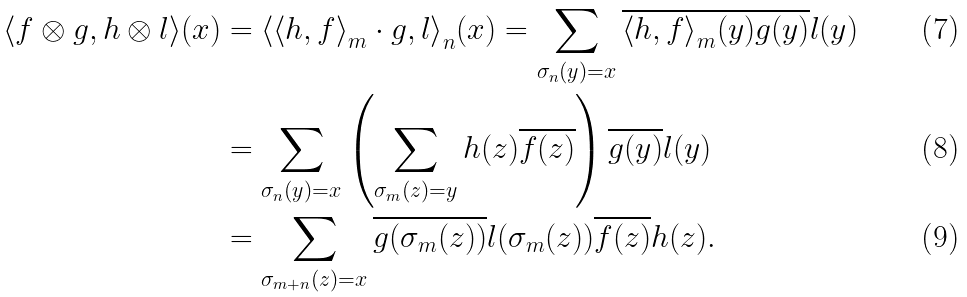Convert formula to latex. <formula><loc_0><loc_0><loc_500><loc_500>\langle f \otimes g , h \otimes l \rangle ( x ) & = { \langle { \langle h , f \rangle } _ { m } \cdot g , l \rangle } _ { n } ( x ) = \sum _ { \sigma _ { n } ( y ) = x } \overline { { \langle h , f \rangle } _ { m } ( y ) } \overline { g ( y ) } l ( y ) \\ & = \sum _ { \sigma _ { n } ( y ) = x } \left ( \sum _ { \sigma _ { m } ( z ) = y } h ( z ) \overline { f ( z ) } \right ) \overline { g ( y ) } l ( y ) \\ & = \sum _ { \sigma _ { m + n } ( z ) = x } \overline { g ( \sigma _ { m } ( z ) ) } l ( \sigma _ { m } ( z ) ) \overline { f ( z ) } h ( z ) .</formula> 